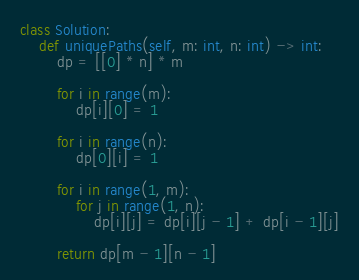Convert code to text. <code><loc_0><loc_0><loc_500><loc_500><_Python_>class Solution:
    def uniquePaths(self, m: int, n: int) -> int:
        dp = [[0] * n] * m

        for i in range(m):
            dp[i][0] = 1

        for i in range(n):
            dp[0][i] = 1

        for i in range(1, m):
            for j in range(1, n):
                dp[i][j] = dp[i][j - 1] + dp[i - 1][j]

        return dp[m - 1][n - 1]
</code> 